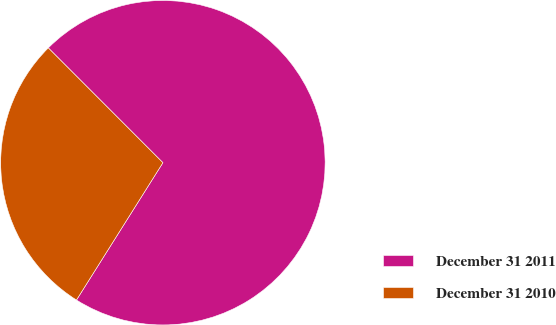Convert chart. <chart><loc_0><loc_0><loc_500><loc_500><pie_chart><fcel>December 31 2011<fcel>December 31 2010<nl><fcel>71.43%<fcel>28.57%<nl></chart> 